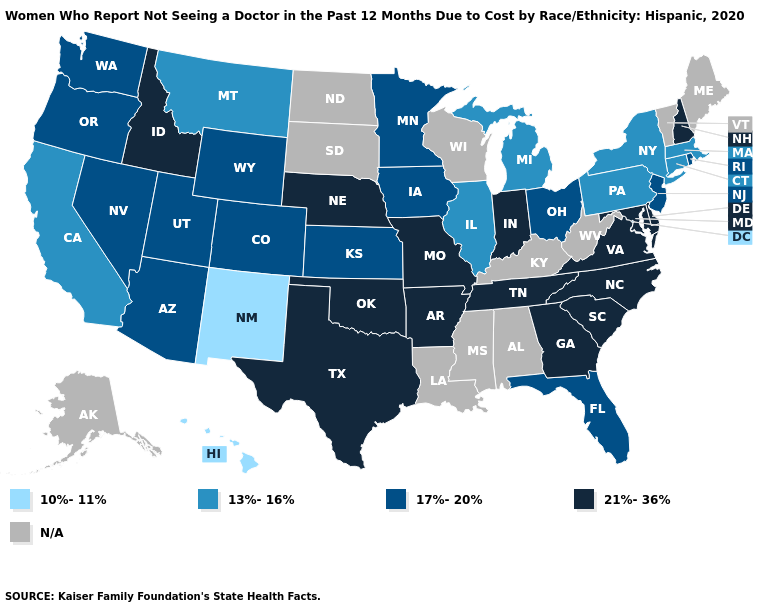Name the states that have a value in the range N/A?
Quick response, please. Alabama, Alaska, Kentucky, Louisiana, Maine, Mississippi, North Dakota, South Dakota, Vermont, West Virginia, Wisconsin. What is the lowest value in the South?
Quick response, please. 17%-20%. Does Florida have the highest value in the South?
Be succinct. No. Among the states that border Iowa , does Missouri have the highest value?
Quick response, please. Yes. Does Florida have the highest value in the South?
Write a very short answer. No. Which states hav the highest value in the West?
Short answer required. Idaho. Which states have the lowest value in the USA?
Write a very short answer. Hawaii, New Mexico. Does the map have missing data?
Quick response, please. Yes. Name the states that have a value in the range 10%-11%?
Keep it brief. Hawaii, New Mexico. What is the value of Nevada?
Quick response, please. 17%-20%. What is the value of Virginia?
Keep it brief. 21%-36%. Among the states that border Vermont , does New Hampshire have the highest value?
Concise answer only. Yes. What is the value of Oregon?
Answer briefly. 17%-20%. What is the highest value in the USA?
Quick response, please. 21%-36%. What is the value of Maryland?
Short answer required. 21%-36%. 